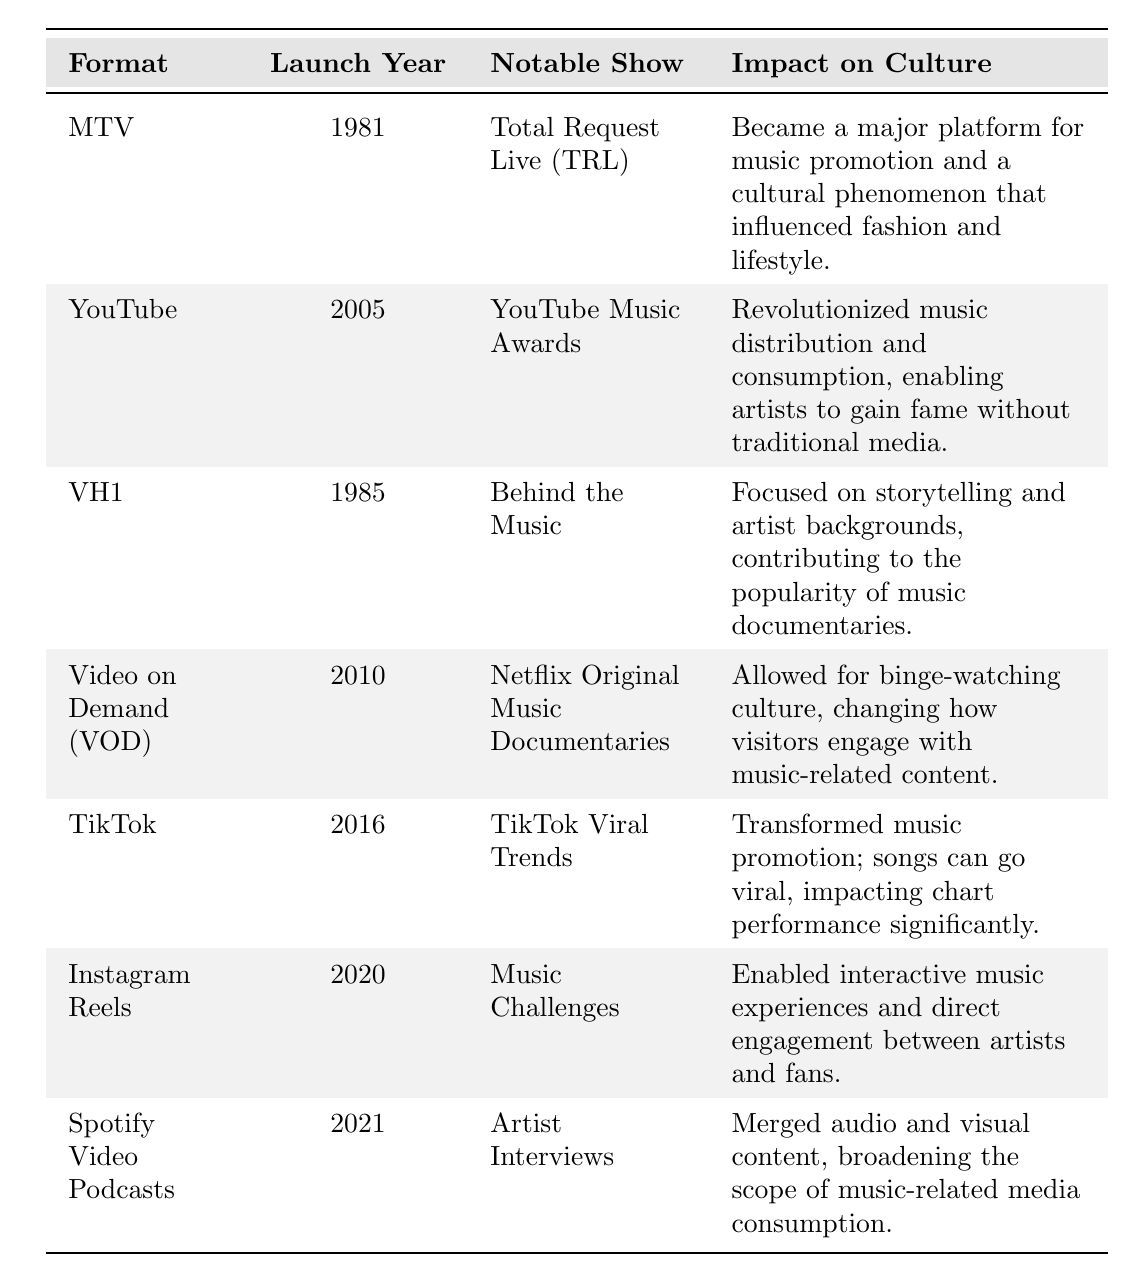What year did MTV launch? MTV is listed with the launch year of 1981 in the table.
Answer: 1981 Which format was launched in 2010? The table indicates that the format launched in 2010 is Video on Demand (VOD).
Answer: Video on Demand (VOD) What notable show is associated with YouTube? YouTube is associated with the notable show "YouTube Music Awards."
Answer: YouTube Music Awards True or False: VH1 was launched before MTV. According to the table, VH1 launched in 1985 while MTV launched in 1981, so this statement is false.
Answer: False What is the impact on culture of TikTok according to the table? The table states that TikTok transformed music promotion and allowed songs to go viral, significantly impacting chart performance.
Answer: Transformed music promotion and impacted chart performance What notable show was launched after TikTok? Instagram Reels was launched after TikTok and is associated with the notable show "Music Challenges."
Answer: Music Challenges Which music video format had the most recent launch year? The table shows that Instagram Reels, launched in 2020, is the most recent format listed.
Answer: Instagram Reels How many formats were launched before 2000? From the table, MTV, VH1, and YouTube were launched before 2000, making a total of three formats.
Answer: 3 What is the common theme in the impacts of both MTV and YouTube on culture? Both MTV and YouTube significantly influenced music promotion and artists’ exposure to the public according to the table.
Answer: Influence on music promotion and artist exposure What notable show is linked to Spotify Video Podcasts, and what is its cultural impact? Spotify Video Podcasts is linked to "Artist Interviews" and has broadened the scope of music-related media consumption.
Answer: Artist Interviews; broadened music media consumption If we consider the launch years, how many years passed between the launch of MTV and TikTok? MTV was launched in 1981 and TikTok in 2016, so 2016 - 1981 = 35 years passed between their launches.
Answer: 35 years What percentage of the formats listed in the table launched after 2010? There are 7 formats total, with 3 formats (TikTok, Instagram Reels, Spotify Video Podcasts) launched after 2010, which makes (3/7)*100 = approximately 42.86%.
Answer: Approximately 42.86% 